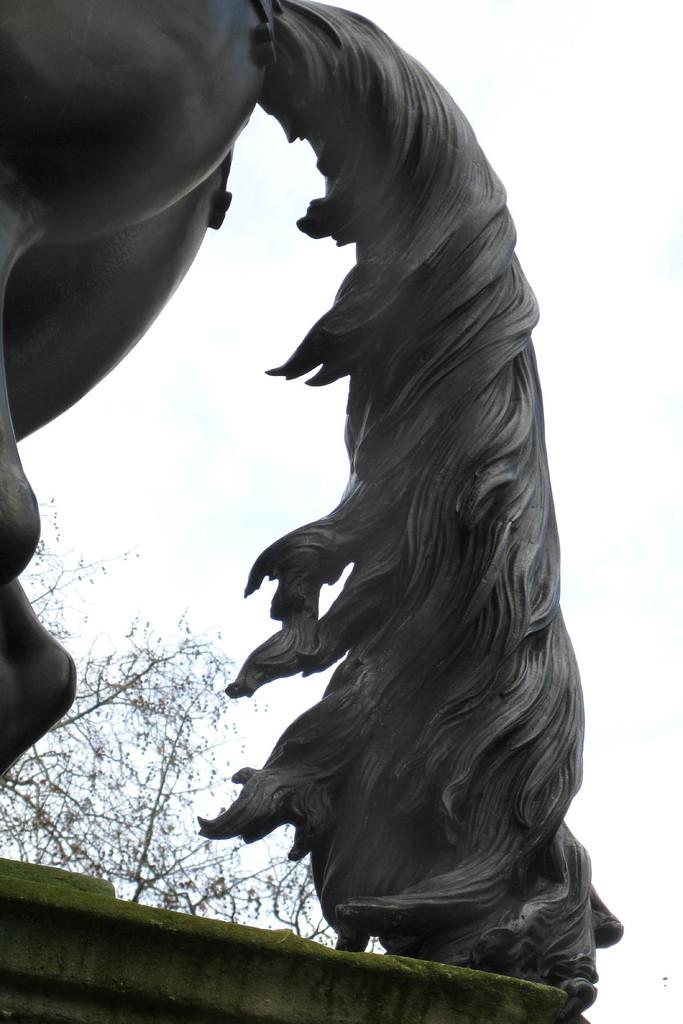What type of artwork is featured in the image? There is a sculpture of an animal in the image. What other natural element can be seen in the image? There is a tree in the image. What is visible in the background of the image? The sky is visible in the image. What month is depicted on the map in the image? There is no map present in the image, so it is not possible to determine the month depicted. 